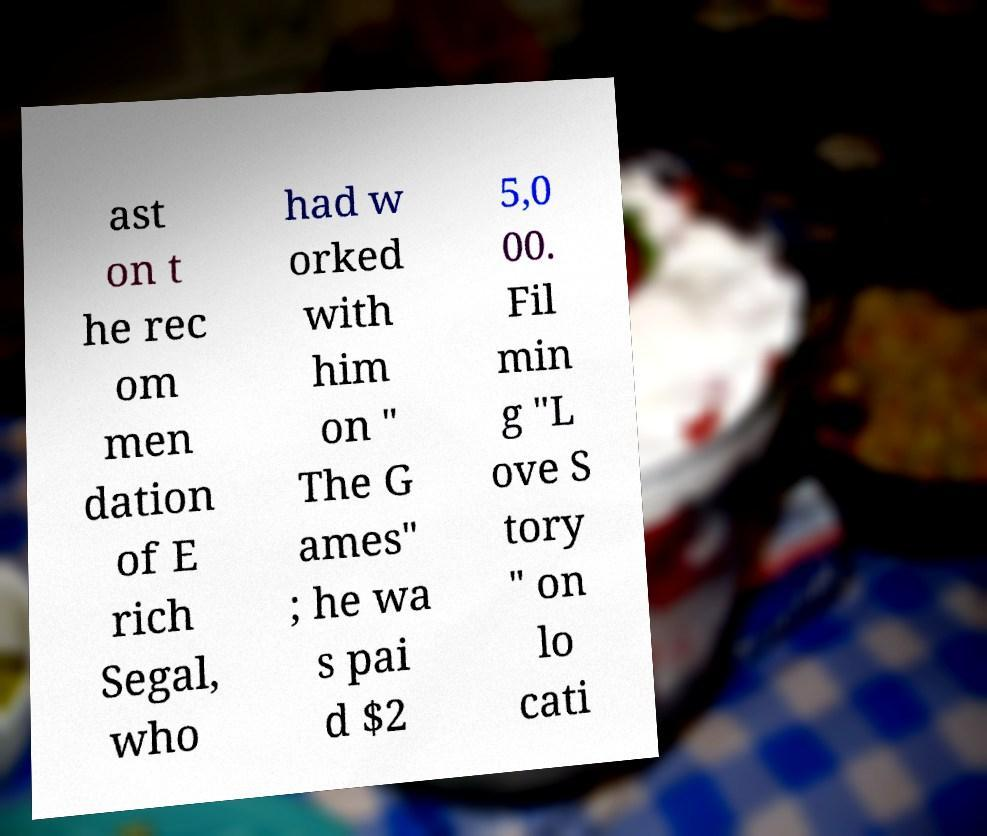Please identify and transcribe the text found in this image. ast on t he rec om men dation of E rich Segal, who had w orked with him on " The G ames" ; he wa s pai d $2 5,0 00. Fil min g "L ove S tory " on lo cati 